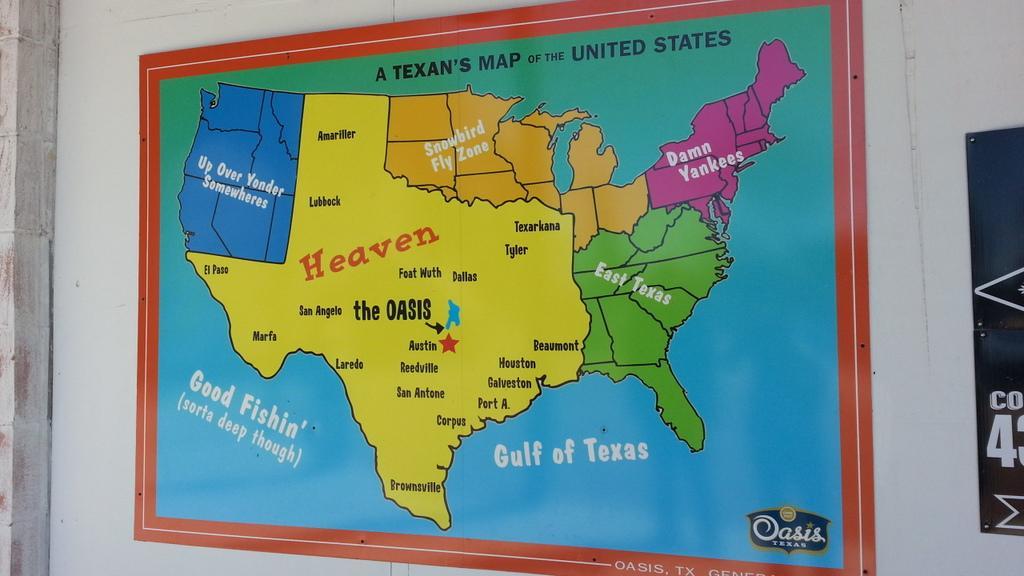In one or two sentences, can you explain what this image depicts? In this image we can see a map of united states which is attached to a wall which is in white color. 